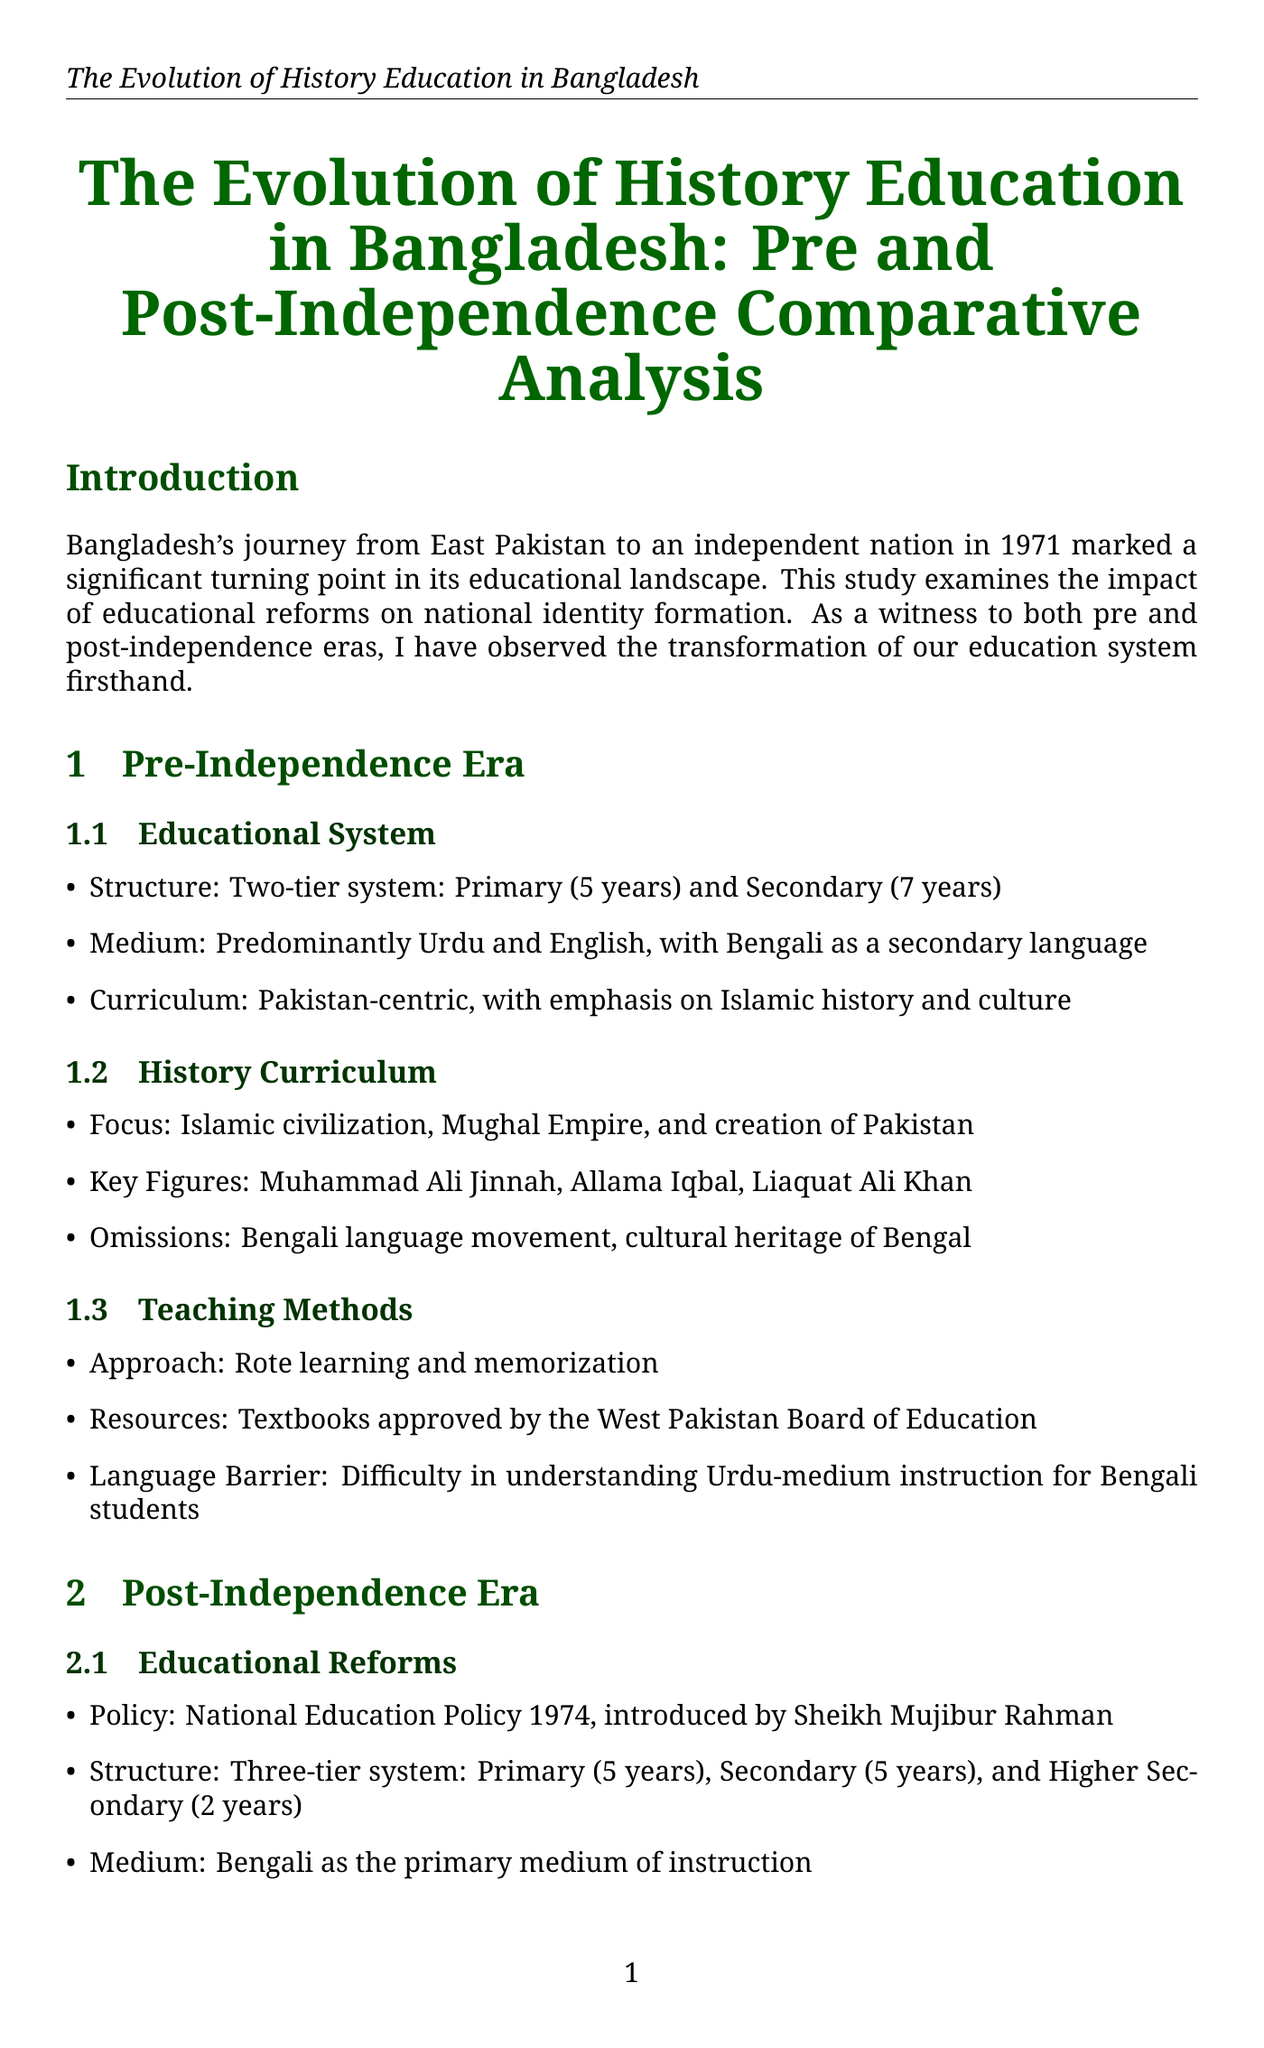What was the primary medium of instruction in the pre-independence era? The pre-independence era primarily used Urdu and English as the medium of instruction.
Answer: Urdu and English Which policy introduced in 1974 significantly changed the educational system? The National Education Policy 1974 introduced significant changes in the educational system post-independence.
Answer: National Education Policy 1974 Who are some key figures included in the post-independence history curriculum? The post-independence history curriculum includes key figures like Sheikh Mujibur Rahman, Kazi Nazrul Islam, and Begum Rokeya.
Answer: Sheikh Mujibur Rahman, Kazi Nazrul Islam, Begum Rokeya What challenge is highlighted regarding access to educational resources? The document mentions limited access to quality educational materials as a challenge, especially in rural areas.
Answer: Limited access to quality educational materials What approach is emphasized in modern teaching methods post-independence? Modern teaching methods emphasize critical thinking and analytical skills development.
Answer: Critical thinking and analytical skills development What significant event is annually observed in educational institutions to promote historical awareness? Independence Day and Victory Day are annually observed in educational institutions to promote historical awareness.
Answer: Independence Day and Victory Day What is a key recommendation for future curriculum development? A key recommendation is the regular review and update of the history syllabus with input from diverse stakeholders.
Answer: Regular review and update of history syllabus How has the history curriculum shifted post-independence? The history curriculum has shifted from being Pakistan-centric to being Bangladesh-focused.
Answer: Bangladesh-focused What theme reflects the revival of Bengali culture in schools? The celebration of Bengali New Year (Pohela Boishakh) in schools reflects the revival of Bengali culture.
Answer: Pohela Boishakh 